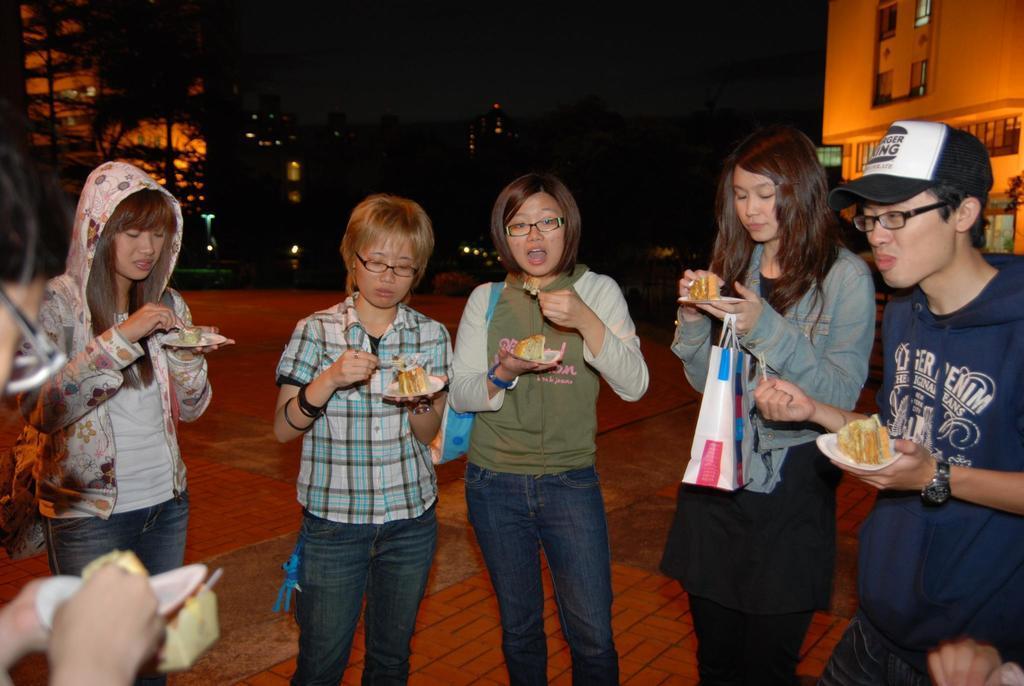How would you summarize this image in a sentence or two? In this image I can see a man and women are standing. I can see few of them are wearing specs and I can see most of them are wearing jackets. I can see all of them are holding spoons and plates. In these places I can see food and in the background I can see a building. I can also see this image is little bit in dark from background. 